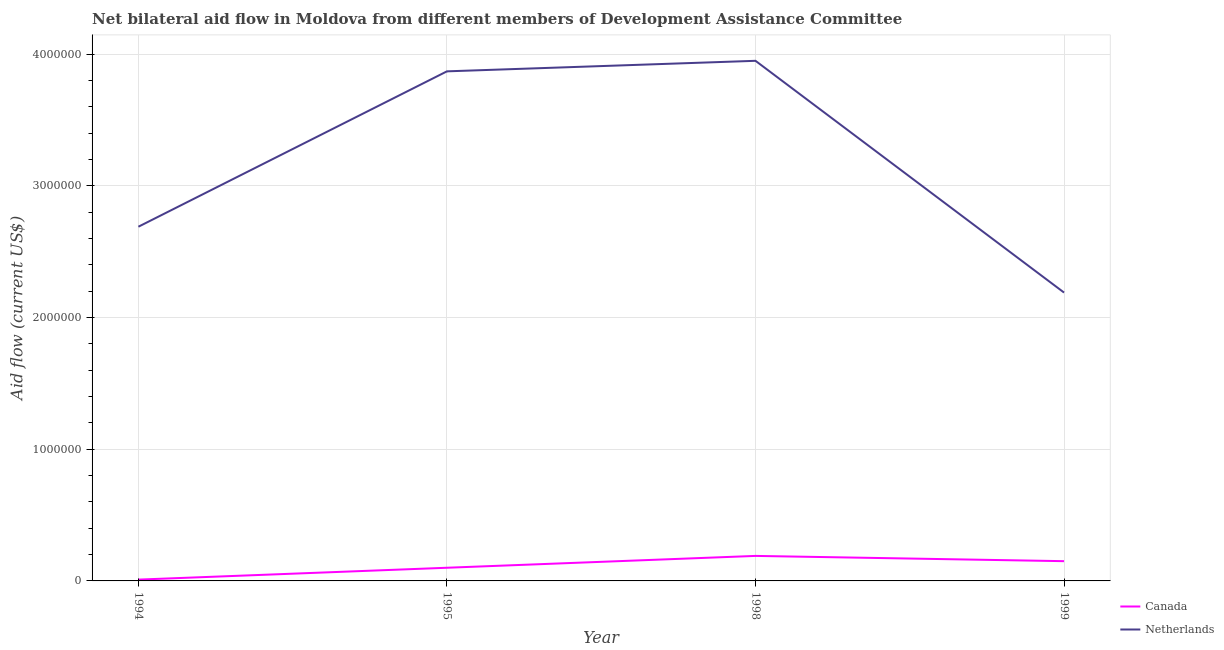How many different coloured lines are there?
Your answer should be very brief. 2. Is the number of lines equal to the number of legend labels?
Give a very brief answer. Yes. What is the amount of aid given by canada in 1994?
Provide a short and direct response. 10000. Across all years, what is the maximum amount of aid given by netherlands?
Ensure brevity in your answer.  3.95e+06. Across all years, what is the minimum amount of aid given by netherlands?
Keep it short and to the point. 2.19e+06. What is the total amount of aid given by canada in the graph?
Provide a succinct answer. 4.50e+05. What is the difference between the amount of aid given by netherlands in 1995 and that in 1999?
Offer a terse response. 1.68e+06. What is the difference between the amount of aid given by canada in 1994 and the amount of aid given by netherlands in 1998?
Offer a terse response. -3.94e+06. What is the average amount of aid given by netherlands per year?
Provide a short and direct response. 3.18e+06. In the year 1995, what is the difference between the amount of aid given by netherlands and amount of aid given by canada?
Your answer should be compact. 3.77e+06. In how many years, is the amount of aid given by canada greater than 2800000 US$?
Keep it short and to the point. 0. What is the ratio of the amount of aid given by netherlands in 1998 to that in 1999?
Offer a terse response. 1.8. Is the amount of aid given by netherlands in 1995 less than that in 1999?
Offer a very short reply. No. What is the difference between the highest and the lowest amount of aid given by canada?
Offer a very short reply. 1.80e+05. Does the amount of aid given by canada monotonically increase over the years?
Provide a short and direct response. No. Is the amount of aid given by canada strictly greater than the amount of aid given by netherlands over the years?
Ensure brevity in your answer.  No. Is the amount of aid given by canada strictly less than the amount of aid given by netherlands over the years?
Your answer should be compact. Yes. Are the values on the major ticks of Y-axis written in scientific E-notation?
Your answer should be compact. No. Does the graph contain any zero values?
Provide a short and direct response. No. Does the graph contain grids?
Provide a succinct answer. Yes. How are the legend labels stacked?
Your answer should be compact. Vertical. What is the title of the graph?
Keep it short and to the point. Net bilateral aid flow in Moldova from different members of Development Assistance Committee. What is the label or title of the X-axis?
Make the answer very short. Year. What is the label or title of the Y-axis?
Provide a short and direct response. Aid flow (current US$). What is the Aid flow (current US$) in Netherlands in 1994?
Give a very brief answer. 2.69e+06. What is the Aid flow (current US$) of Netherlands in 1995?
Your response must be concise. 3.87e+06. What is the Aid flow (current US$) in Canada in 1998?
Provide a succinct answer. 1.90e+05. What is the Aid flow (current US$) of Netherlands in 1998?
Make the answer very short. 3.95e+06. What is the Aid flow (current US$) of Netherlands in 1999?
Make the answer very short. 2.19e+06. Across all years, what is the maximum Aid flow (current US$) in Canada?
Keep it short and to the point. 1.90e+05. Across all years, what is the maximum Aid flow (current US$) in Netherlands?
Make the answer very short. 3.95e+06. Across all years, what is the minimum Aid flow (current US$) of Canada?
Offer a terse response. 10000. Across all years, what is the minimum Aid flow (current US$) in Netherlands?
Your answer should be compact. 2.19e+06. What is the total Aid flow (current US$) of Canada in the graph?
Your answer should be compact. 4.50e+05. What is the total Aid flow (current US$) of Netherlands in the graph?
Your response must be concise. 1.27e+07. What is the difference between the Aid flow (current US$) in Netherlands in 1994 and that in 1995?
Offer a terse response. -1.18e+06. What is the difference between the Aid flow (current US$) in Netherlands in 1994 and that in 1998?
Your answer should be very brief. -1.26e+06. What is the difference between the Aid flow (current US$) in Canada in 1994 and that in 1999?
Provide a short and direct response. -1.40e+05. What is the difference between the Aid flow (current US$) in Netherlands in 1994 and that in 1999?
Keep it short and to the point. 5.00e+05. What is the difference between the Aid flow (current US$) in Canada in 1995 and that in 1998?
Ensure brevity in your answer.  -9.00e+04. What is the difference between the Aid flow (current US$) in Netherlands in 1995 and that in 1999?
Offer a terse response. 1.68e+06. What is the difference between the Aid flow (current US$) in Canada in 1998 and that in 1999?
Make the answer very short. 4.00e+04. What is the difference between the Aid flow (current US$) in Netherlands in 1998 and that in 1999?
Provide a succinct answer. 1.76e+06. What is the difference between the Aid flow (current US$) of Canada in 1994 and the Aid flow (current US$) of Netherlands in 1995?
Offer a very short reply. -3.86e+06. What is the difference between the Aid flow (current US$) in Canada in 1994 and the Aid flow (current US$) in Netherlands in 1998?
Give a very brief answer. -3.94e+06. What is the difference between the Aid flow (current US$) in Canada in 1994 and the Aid flow (current US$) in Netherlands in 1999?
Give a very brief answer. -2.18e+06. What is the difference between the Aid flow (current US$) in Canada in 1995 and the Aid flow (current US$) in Netherlands in 1998?
Provide a succinct answer. -3.85e+06. What is the difference between the Aid flow (current US$) of Canada in 1995 and the Aid flow (current US$) of Netherlands in 1999?
Provide a succinct answer. -2.09e+06. What is the average Aid flow (current US$) in Canada per year?
Offer a very short reply. 1.12e+05. What is the average Aid flow (current US$) of Netherlands per year?
Keep it short and to the point. 3.18e+06. In the year 1994, what is the difference between the Aid flow (current US$) of Canada and Aid flow (current US$) of Netherlands?
Provide a succinct answer. -2.68e+06. In the year 1995, what is the difference between the Aid flow (current US$) in Canada and Aid flow (current US$) in Netherlands?
Provide a short and direct response. -3.77e+06. In the year 1998, what is the difference between the Aid flow (current US$) in Canada and Aid flow (current US$) in Netherlands?
Offer a terse response. -3.76e+06. In the year 1999, what is the difference between the Aid flow (current US$) in Canada and Aid flow (current US$) in Netherlands?
Ensure brevity in your answer.  -2.04e+06. What is the ratio of the Aid flow (current US$) in Netherlands in 1994 to that in 1995?
Offer a terse response. 0.7. What is the ratio of the Aid flow (current US$) in Canada in 1994 to that in 1998?
Provide a succinct answer. 0.05. What is the ratio of the Aid flow (current US$) in Netherlands in 1994 to that in 1998?
Your answer should be very brief. 0.68. What is the ratio of the Aid flow (current US$) in Canada in 1994 to that in 1999?
Ensure brevity in your answer.  0.07. What is the ratio of the Aid flow (current US$) in Netherlands in 1994 to that in 1999?
Give a very brief answer. 1.23. What is the ratio of the Aid flow (current US$) in Canada in 1995 to that in 1998?
Offer a very short reply. 0.53. What is the ratio of the Aid flow (current US$) of Netherlands in 1995 to that in 1998?
Your answer should be very brief. 0.98. What is the ratio of the Aid flow (current US$) in Canada in 1995 to that in 1999?
Ensure brevity in your answer.  0.67. What is the ratio of the Aid flow (current US$) of Netherlands in 1995 to that in 1999?
Offer a very short reply. 1.77. What is the ratio of the Aid flow (current US$) of Canada in 1998 to that in 1999?
Your response must be concise. 1.27. What is the ratio of the Aid flow (current US$) in Netherlands in 1998 to that in 1999?
Offer a very short reply. 1.8. What is the difference between the highest and the second highest Aid flow (current US$) of Netherlands?
Offer a very short reply. 8.00e+04. What is the difference between the highest and the lowest Aid flow (current US$) in Netherlands?
Provide a succinct answer. 1.76e+06. 